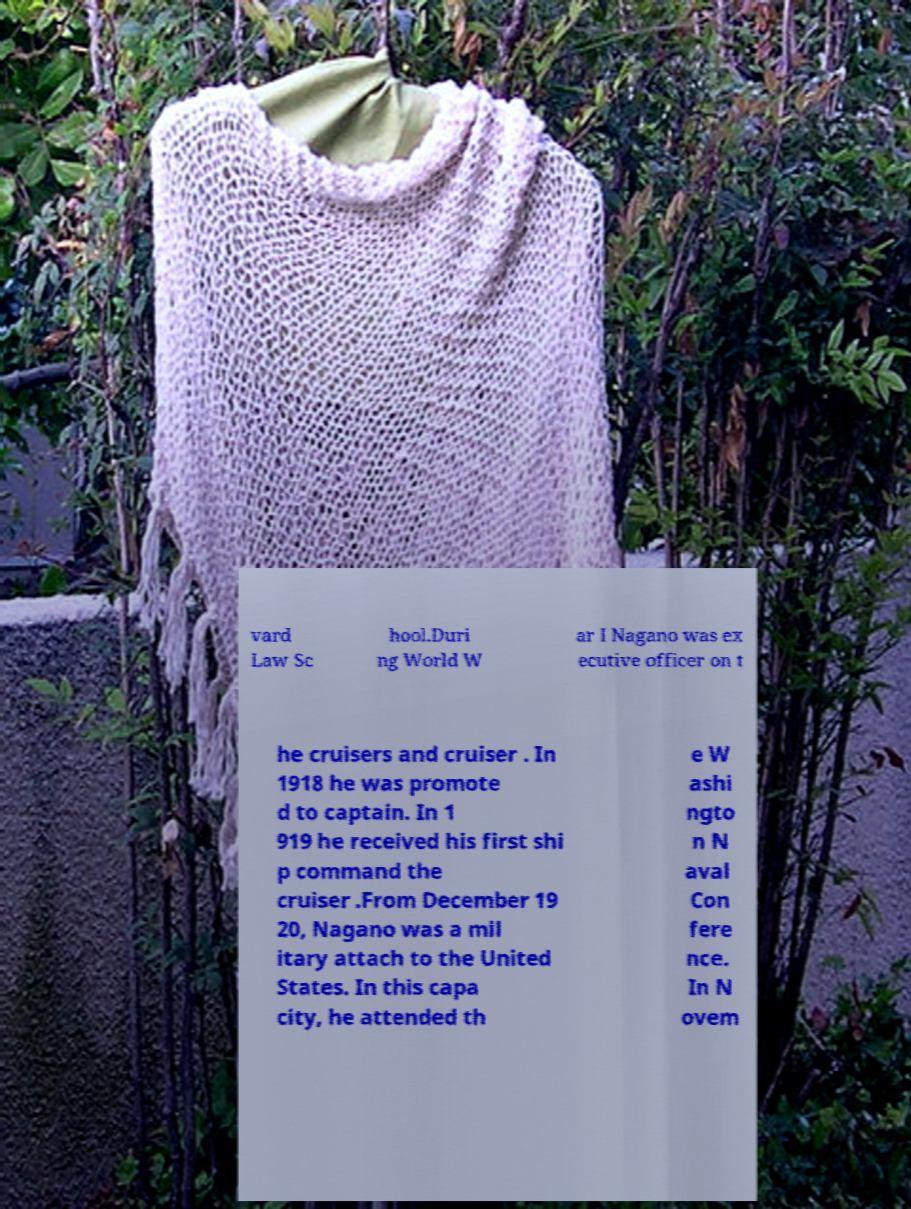There's text embedded in this image that I need extracted. Can you transcribe it verbatim? vard Law Sc hool.Duri ng World W ar I Nagano was ex ecutive officer on t he cruisers and cruiser . In 1918 he was promote d to captain. In 1 919 he received his first shi p command the cruiser .From December 19 20, Nagano was a mil itary attach to the United States. In this capa city, he attended th e W ashi ngto n N aval Con fere nce. In N ovem 